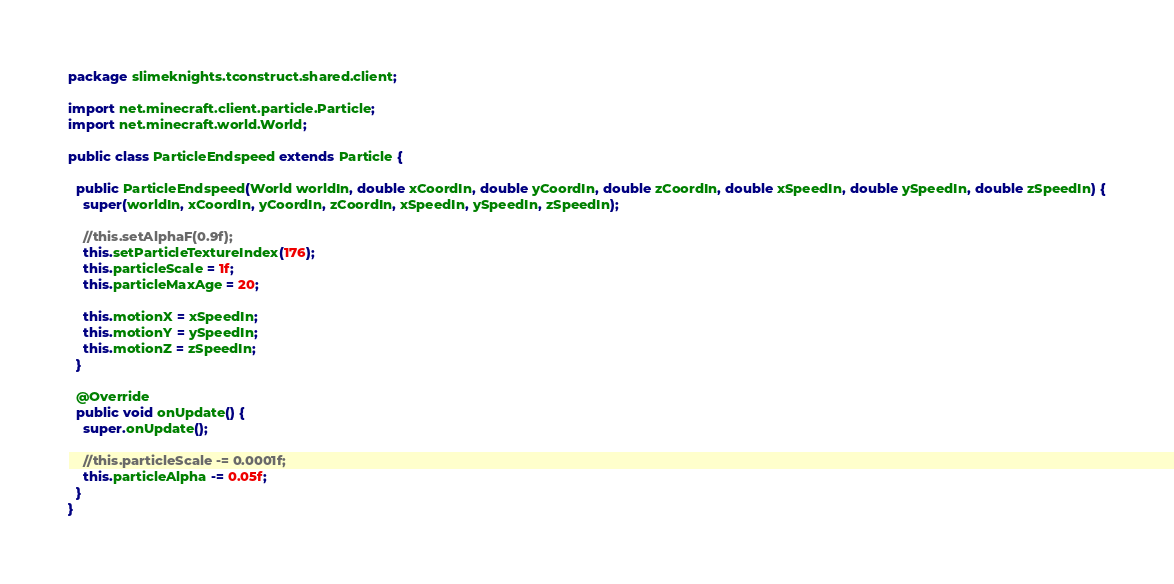<code> <loc_0><loc_0><loc_500><loc_500><_Java_>package slimeknights.tconstruct.shared.client;

import net.minecraft.client.particle.Particle;
import net.minecraft.world.World;

public class ParticleEndspeed extends Particle {

  public ParticleEndspeed(World worldIn, double xCoordIn, double yCoordIn, double zCoordIn, double xSpeedIn, double ySpeedIn, double zSpeedIn) {
    super(worldIn, xCoordIn, yCoordIn, zCoordIn, xSpeedIn, ySpeedIn, zSpeedIn);

    //this.setAlphaF(0.9f);
    this.setParticleTextureIndex(176);
    this.particleScale = 1f;
    this.particleMaxAge = 20;

    this.motionX = xSpeedIn;
    this.motionY = ySpeedIn;
    this.motionZ = zSpeedIn;
  }

  @Override
  public void onUpdate() {
    super.onUpdate();

    //this.particleScale -= 0.0001f;
    this.particleAlpha -= 0.05f;
  }
}
</code> 